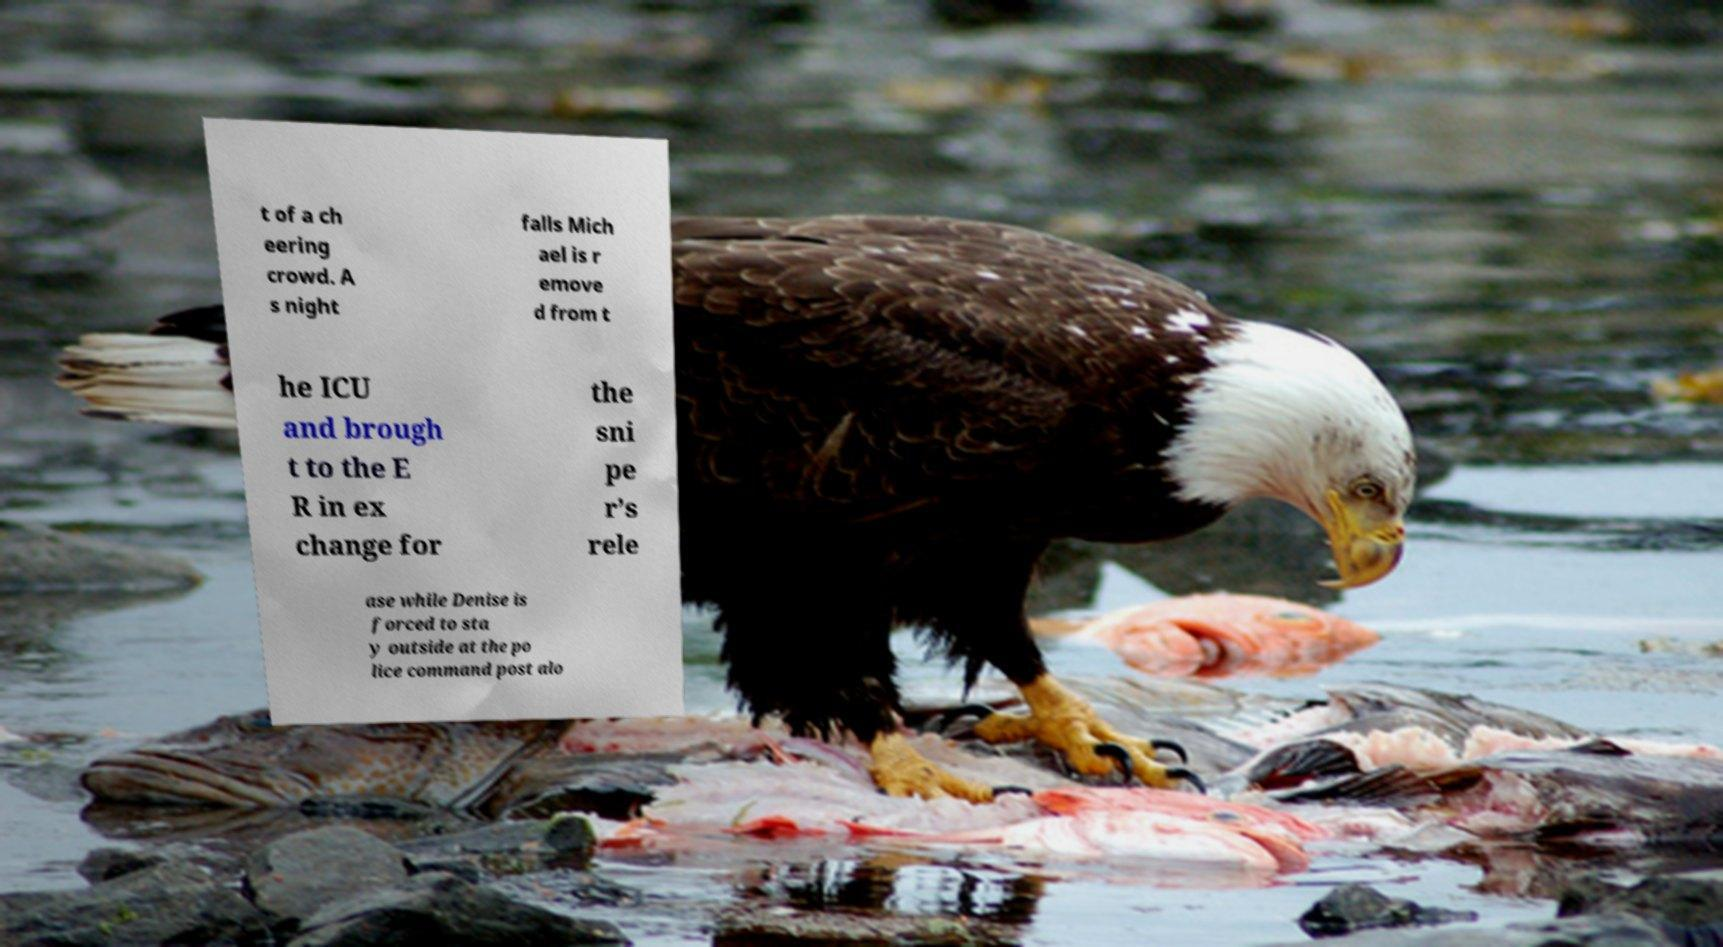I need the written content from this picture converted into text. Can you do that? t of a ch eering crowd. A s night falls Mich ael is r emove d from t he ICU and brough t to the E R in ex change for the sni pe r’s rele ase while Denise is forced to sta y outside at the po lice command post alo 